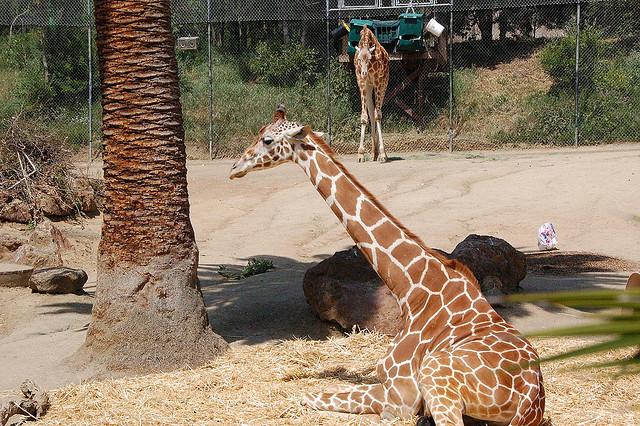Where was the picture taken of the giraffe?
Short answer required. Zoo. What is the animal doing?
Write a very short answer. Sitting. Are the animals enclosed?
Concise answer only. Yes. Is the giraffe beside the tree asleep?
Keep it brief. No. 